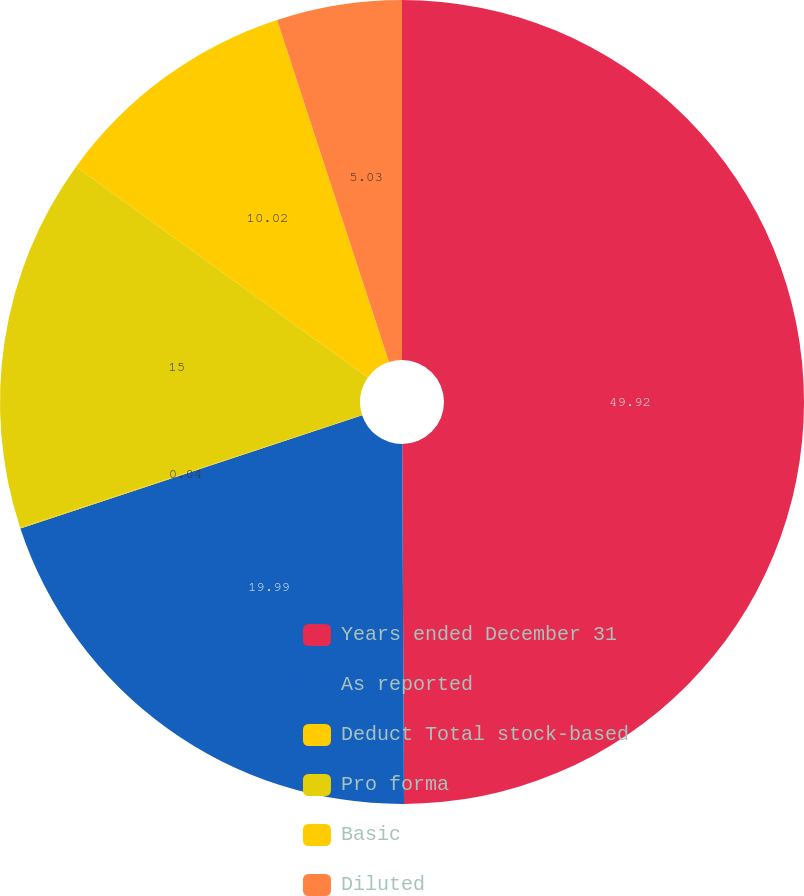Convert chart. <chart><loc_0><loc_0><loc_500><loc_500><pie_chart><fcel>Years ended December 31<fcel>As reported<fcel>Deduct Total stock-based<fcel>Pro forma<fcel>Basic<fcel>Diluted<nl><fcel>49.92%<fcel>19.99%<fcel>0.04%<fcel>15.0%<fcel>10.02%<fcel>5.03%<nl></chart> 